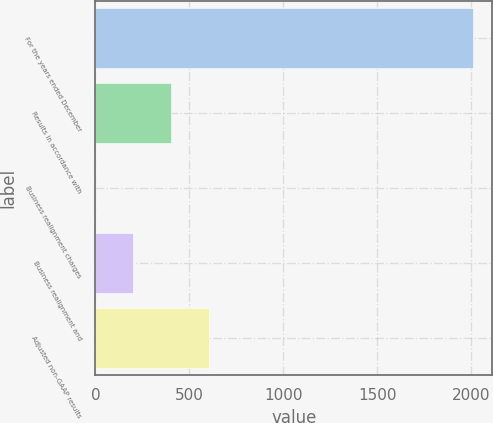<chart> <loc_0><loc_0><loc_500><loc_500><bar_chart><fcel>For the years ended December<fcel>Results in accordance with<fcel>Business realignment charges<fcel>Business realignment and<fcel>Adjusted non-GAAP results<nl><fcel>2010<fcel>402.04<fcel>0.04<fcel>201.04<fcel>603.04<nl></chart> 